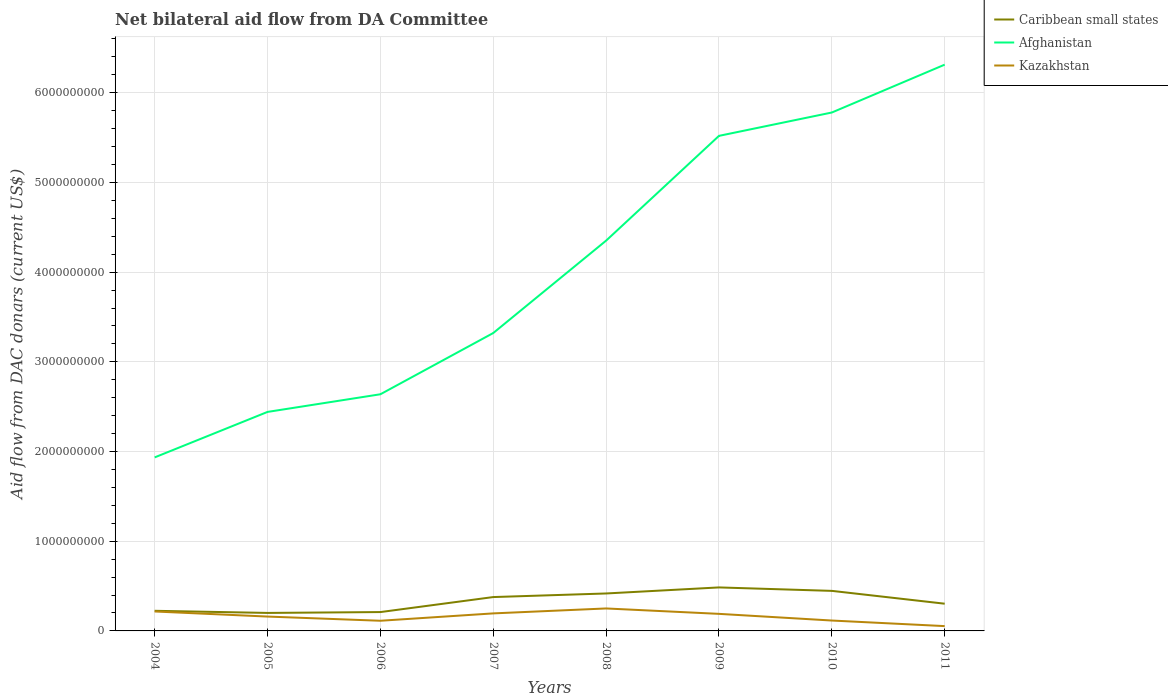How many different coloured lines are there?
Provide a short and direct response. 3. Does the line corresponding to Afghanistan intersect with the line corresponding to Kazakhstan?
Offer a terse response. No. Across all years, what is the maximum aid flow in in Kazakhstan?
Provide a succinct answer. 5.37e+07. In which year was the aid flow in in Kazakhstan maximum?
Offer a very short reply. 2011. What is the total aid flow in in Caribbean small states in the graph?
Offer a very short reply. 1.82e+08. What is the difference between the highest and the second highest aid flow in in Caribbean small states?
Your answer should be compact. 2.84e+08. How many years are there in the graph?
Your answer should be very brief. 8. What is the difference between two consecutive major ticks on the Y-axis?
Keep it short and to the point. 1.00e+09. Are the values on the major ticks of Y-axis written in scientific E-notation?
Your response must be concise. No. Does the graph contain grids?
Offer a very short reply. Yes. Where does the legend appear in the graph?
Provide a short and direct response. Top right. How many legend labels are there?
Your response must be concise. 3. What is the title of the graph?
Provide a short and direct response. Net bilateral aid flow from DA Committee. What is the label or title of the Y-axis?
Give a very brief answer. Aid flow from DAC donars (current US$). What is the Aid flow from DAC donars (current US$) in Caribbean small states in 2004?
Your response must be concise. 2.24e+08. What is the Aid flow from DAC donars (current US$) of Afghanistan in 2004?
Offer a very short reply. 1.93e+09. What is the Aid flow from DAC donars (current US$) in Kazakhstan in 2004?
Your response must be concise. 2.17e+08. What is the Aid flow from DAC donars (current US$) in Caribbean small states in 2005?
Provide a succinct answer. 2.01e+08. What is the Aid flow from DAC donars (current US$) of Afghanistan in 2005?
Offer a terse response. 2.44e+09. What is the Aid flow from DAC donars (current US$) of Kazakhstan in 2005?
Provide a succinct answer. 1.60e+08. What is the Aid flow from DAC donars (current US$) of Caribbean small states in 2006?
Ensure brevity in your answer.  2.10e+08. What is the Aid flow from DAC donars (current US$) of Afghanistan in 2006?
Your response must be concise. 2.64e+09. What is the Aid flow from DAC donars (current US$) of Kazakhstan in 2006?
Ensure brevity in your answer.  1.13e+08. What is the Aid flow from DAC donars (current US$) in Caribbean small states in 2007?
Provide a succinct answer. 3.77e+08. What is the Aid flow from DAC donars (current US$) of Afghanistan in 2007?
Offer a terse response. 3.32e+09. What is the Aid flow from DAC donars (current US$) in Kazakhstan in 2007?
Your response must be concise. 1.95e+08. What is the Aid flow from DAC donars (current US$) of Caribbean small states in 2008?
Your answer should be very brief. 4.18e+08. What is the Aid flow from DAC donars (current US$) of Afghanistan in 2008?
Provide a succinct answer. 4.35e+09. What is the Aid flow from DAC donars (current US$) of Kazakhstan in 2008?
Keep it short and to the point. 2.50e+08. What is the Aid flow from DAC donars (current US$) of Caribbean small states in 2009?
Give a very brief answer. 4.85e+08. What is the Aid flow from DAC donars (current US$) of Afghanistan in 2009?
Provide a succinct answer. 5.52e+09. What is the Aid flow from DAC donars (current US$) of Kazakhstan in 2009?
Provide a short and direct response. 1.90e+08. What is the Aid flow from DAC donars (current US$) in Caribbean small states in 2010?
Your answer should be compact. 4.46e+08. What is the Aid flow from DAC donars (current US$) in Afghanistan in 2010?
Give a very brief answer. 5.78e+09. What is the Aid flow from DAC donars (current US$) in Kazakhstan in 2010?
Ensure brevity in your answer.  1.16e+08. What is the Aid flow from DAC donars (current US$) in Caribbean small states in 2011?
Ensure brevity in your answer.  3.03e+08. What is the Aid flow from DAC donars (current US$) in Afghanistan in 2011?
Provide a short and direct response. 6.31e+09. What is the Aid flow from DAC donars (current US$) of Kazakhstan in 2011?
Ensure brevity in your answer.  5.37e+07. Across all years, what is the maximum Aid flow from DAC donars (current US$) of Caribbean small states?
Ensure brevity in your answer.  4.85e+08. Across all years, what is the maximum Aid flow from DAC donars (current US$) in Afghanistan?
Provide a short and direct response. 6.31e+09. Across all years, what is the maximum Aid flow from DAC donars (current US$) of Kazakhstan?
Your answer should be compact. 2.50e+08. Across all years, what is the minimum Aid flow from DAC donars (current US$) of Caribbean small states?
Your answer should be compact. 2.01e+08. Across all years, what is the minimum Aid flow from DAC donars (current US$) of Afghanistan?
Give a very brief answer. 1.93e+09. Across all years, what is the minimum Aid flow from DAC donars (current US$) in Kazakhstan?
Your answer should be very brief. 5.37e+07. What is the total Aid flow from DAC donars (current US$) in Caribbean small states in the graph?
Make the answer very short. 2.67e+09. What is the total Aid flow from DAC donars (current US$) of Afghanistan in the graph?
Make the answer very short. 3.23e+1. What is the total Aid flow from DAC donars (current US$) in Kazakhstan in the graph?
Provide a short and direct response. 1.30e+09. What is the difference between the Aid flow from DAC donars (current US$) of Caribbean small states in 2004 and that in 2005?
Your answer should be compact. 2.37e+07. What is the difference between the Aid flow from DAC donars (current US$) in Afghanistan in 2004 and that in 2005?
Offer a very short reply. -5.07e+08. What is the difference between the Aid flow from DAC donars (current US$) in Kazakhstan in 2004 and that in 2005?
Provide a short and direct response. 5.66e+07. What is the difference between the Aid flow from DAC donars (current US$) in Caribbean small states in 2004 and that in 2006?
Your response must be concise. 1.42e+07. What is the difference between the Aid flow from DAC donars (current US$) in Afghanistan in 2004 and that in 2006?
Your answer should be very brief. -7.04e+08. What is the difference between the Aid flow from DAC donars (current US$) in Kazakhstan in 2004 and that in 2006?
Make the answer very short. 1.03e+08. What is the difference between the Aid flow from DAC donars (current US$) of Caribbean small states in 2004 and that in 2007?
Provide a short and direct response. -1.53e+08. What is the difference between the Aid flow from DAC donars (current US$) in Afghanistan in 2004 and that in 2007?
Make the answer very short. -1.39e+09. What is the difference between the Aid flow from DAC donars (current US$) in Kazakhstan in 2004 and that in 2007?
Your response must be concise. 2.12e+07. What is the difference between the Aid flow from DAC donars (current US$) of Caribbean small states in 2004 and that in 2008?
Provide a short and direct response. -1.93e+08. What is the difference between the Aid flow from DAC donars (current US$) in Afghanistan in 2004 and that in 2008?
Provide a short and direct response. -2.42e+09. What is the difference between the Aid flow from DAC donars (current US$) in Kazakhstan in 2004 and that in 2008?
Ensure brevity in your answer.  -3.38e+07. What is the difference between the Aid flow from DAC donars (current US$) of Caribbean small states in 2004 and that in 2009?
Offer a very short reply. -2.61e+08. What is the difference between the Aid flow from DAC donars (current US$) in Afghanistan in 2004 and that in 2009?
Offer a terse response. -3.58e+09. What is the difference between the Aid flow from DAC donars (current US$) of Kazakhstan in 2004 and that in 2009?
Your response must be concise. 2.64e+07. What is the difference between the Aid flow from DAC donars (current US$) in Caribbean small states in 2004 and that in 2010?
Offer a very short reply. -2.22e+08. What is the difference between the Aid flow from DAC donars (current US$) of Afghanistan in 2004 and that in 2010?
Give a very brief answer. -3.84e+09. What is the difference between the Aid flow from DAC donars (current US$) of Kazakhstan in 2004 and that in 2010?
Your answer should be very brief. 1.01e+08. What is the difference between the Aid flow from DAC donars (current US$) of Caribbean small states in 2004 and that in 2011?
Provide a succinct answer. -7.90e+07. What is the difference between the Aid flow from DAC donars (current US$) of Afghanistan in 2004 and that in 2011?
Your response must be concise. -4.38e+09. What is the difference between the Aid flow from DAC donars (current US$) of Kazakhstan in 2004 and that in 2011?
Give a very brief answer. 1.63e+08. What is the difference between the Aid flow from DAC donars (current US$) of Caribbean small states in 2005 and that in 2006?
Give a very brief answer. -9.56e+06. What is the difference between the Aid flow from DAC donars (current US$) in Afghanistan in 2005 and that in 2006?
Ensure brevity in your answer.  -1.97e+08. What is the difference between the Aid flow from DAC donars (current US$) in Kazakhstan in 2005 and that in 2006?
Give a very brief answer. 4.67e+07. What is the difference between the Aid flow from DAC donars (current US$) in Caribbean small states in 2005 and that in 2007?
Offer a very short reply. -1.77e+08. What is the difference between the Aid flow from DAC donars (current US$) of Afghanistan in 2005 and that in 2007?
Provide a short and direct response. -8.80e+08. What is the difference between the Aid flow from DAC donars (current US$) in Kazakhstan in 2005 and that in 2007?
Make the answer very short. -3.54e+07. What is the difference between the Aid flow from DAC donars (current US$) in Caribbean small states in 2005 and that in 2008?
Keep it short and to the point. -2.17e+08. What is the difference between the Aid flow from DAC donars (current US$) in Afghanistan in 2005 and that in 2008?
Ensure brevity in your answer.  -1.91e+09. What is the difference between the Aid flow from DAC donars (current US$) of Kazakhstan in 2005 and that in 2008?
Your answer should be very brief. -9.04e+07. What is the difference between the Aid flow from DAC donars (current US$) of Caribbean small states in 2005 and that in 2009?
Your response must be concise. -2.84e+08. What is the difference between the Aid flow from DAC donars (current US$) in Afghanistan in 2005 and that in 2009?
Give a very brief answer. -3.08e+09. What is the difference between the Aid flow from DAC donars (current US$) in Kazakhstan in 2005 and that in 2009?
Make the answer very short. -3.02e+07. What is the difference between the Aid flow from DAC donars (current US$) of Caribbean small states in 2005 and that in 2010?
Keep it short and to the point. -2.46e+08. What is the difference between the Aid flow from DAC donars (current US$) in Afghanistan in 2005 and that in 2010?
Keep it short and to the point. -3.34e+09. What is the difference between the Aid flow from DAC donars (current US$) in Kazakhstan in 2005 and that in 2010?
Your answer should be compact. 4.42e+07. What is the difference between the Aid flow from DAC donars (current US$) of Caribbean small states in 2005 and that in 2011?
Your response must be concise. -1.03e+08. What is the difference between the Aid flow from DAC donars (current US$) of Afghanistan in 2005 and that in 2011?
Your answer should be compact. -3.87e+09. What is the difference between the Aid flow from DAC donars (current US$) of Kazakhstan in 2005 and that in 2011?
Offer a very short reply. 1.06e+08. What is the difference between the Aid flow from DAC donars (current US$) in Caribbean small states in 2006 and that in 2007?
Make the answer very short. -1.67e+08. What is the difference between the Aid flow from DAC donars (current US$) of Afghanistan in 2006 and that in 2007?
Ensure brevity in your answer.  -6.83e+08. What is the difference between the Aid flow from DAC donars (current US$) of Kazakhstan in 2006 and that in 2007?
Provide a short and direct response. -8.22e+07. What is the difference between the Aid flow from DAC donars (current US$) in Caribbean small states in 2006 and that in 2008?
Provide a short and direct response. -2.07e+08. What is the difference between the Aid flow from DAC donars (current US$) in Afghanistan in 2006 and that in 2008?
Provide a succinct answer. -1.71e+09. What is the difference between the Aid flow from DAC donars (current US$) of Kazakhstan in 2006 and that in 2008?
Your answer should be very brief. -1.37e+08. What is the difference between the Aid flow from DAC donars (current US$) of Caribbean small states in 2006 and that in 2009?
Keep it short and to the point. -2.75e+08. What is the difference between the Aid flow from DAC donars (current US$) in Afghanistan in 2006 and that in 2009?
Offer a very short reply. -2.88e+09. What is the difference between the Aid flow from DAC donars (current US$) in Kazakhstan in 2006 and that in 2009?
Give a very brief answer. -7.70e+07. What is the difference between the Aid flow from DAC donars (current US$) in Caribbean small states in 2006 and that in 2010?
Make the answer very short. -2.36e+08. What is the difference between the Aid flow from DAC donars (current US$) of Afghanistan in 2006 and that in 2010?
Give a very brief answer. -3.14e+09. What is the difference between the Aid flow from DAC donars (current US$) of Kazakhstan in 2006 and that in 2010?
Give a very brief answer. -2.47e+06. What is the difference between the Aid flow from DAC donars (current US$) of Caribbean small states in 2006 and that in 2011?
Ensure brevity in your answer.  -9.32e+07. What is the difference between the Aid flow from DAC donars (current US$) of Afghanistan in 2006 and that in 2011?
Provide a short and direct response. -3.67e+09. What is the difference between the Aid flow from DAC donars (current US$) in Kazakhstan in 2006 and that in 2011?
Provide a succinct answer. 5.96e+07. What is the difference between the Aid flow from DAC donars (current US$) of Caribbean small states in 2007 and that in 2008?
Provide a succinct answer. -4.00e+07. What is the difference between the Aid flow from DAC donars (current US$) of Afghanistan in 2007 and that in 2008?
Keep it short and to the point. -1.03e+09. What is the difference between the Aid flow from DAC donars (current US$) in Kazakhstan in 2007 and that in 2008?
Your answer should be compact. -5.50e+07. What is the difference between the Aid flow from DAC donars (current US$) of Caribbean small states in 2007 and that in 2009?
Give a very brief answer. -1.08e+08. What is the difference between the Aid flow from DAC donars (current US$) in Afghanistan in 2007 and that in 2009?
Keep it short and to the point. -2.20e+09. What is the difference between the Aid flow from DAC donars (current US$) in Kazakhstan in 2007 and that in 2009?
Give a very brief answer. 5.20e+06. What is the difference between the Aid flow from DAC donars (current US$) in Caribbean small states in 2007 and that in 2010?
Offer a very short reply. -6.90e+07. What is the difference between the Aid flow from DAC donars (current US$) in Afghanistan in 2007 and that in 2010?
Give a very brief answer. -2.46e+09. What is the difference between the Aid flow from DAC donars (current US$) of Kazakhstan in 2007 and that in 2010?
Your response must be concise. 7.97e+07. What is the difference between the Aid flow from DAC donars (current US$) of Caribbean small states in 2007 and that in 2011?
Provide a succinct answer. 7.40e+07. What is the difference between the Aid flow from DAC donars (current US$) in Afghanistan in 2007 and that in 2011?
Your answer should be very brief. -2.99e+09. What is the difference between the Aid flow from DAC donars (current US$) of Kazakhstan in 2007 and that in 2011?
Offer a very short reply. 1.42e+08. What is the difference between the Aid flow from DAC donars (current US$) of Caribbean small states in 2008 and that in 2009?
Provide a short and direct response. -6.75e+07. What is the difference between the Aid flow from DAC donars (current US$) in Afghanistan in 2008 and that in 2009?
Provide a succinct answer. -1.17e+09. What is the difference between the Aid flow from DAC donars (current US$) in Kazakhstan in 2008 and that in 2009?
Offer a very short reply. 6.02e+07. What is the difference between the Aid flow from DAC donars (current US$) of Caribbean small states in 2008 and that in 2010?
Ensure brevity in your answer.  -2.90e+07. What is the difference between the Aid flow from DAC donars (current US$) of Afghanistan in 2008 and that in 2010?
Your answer should be compact. -1.43e+09. What is the difference between the Aid flow from DAC donars (current US$) in Kazakhstan in 2008 and that in 2010?
Make the answer very short. 1.35e+08. What is the difference between the Aid flow from DAC donars (current US$) of Caribbean small states in 2008 and that in 2011?
Offer a very short reply. 1.14e+08. What is the difference between the Aid flow from DAC donars (current US$) in Afghanistan in 2008 and that in 2011?
Provide a succinct answer. -1.96e+09. What is the difference between the Aid flow from DAC donars (current US$) in Kazakhstan in 2008 and that in 2011?
Provide a succinct answer. 1.97e+08. What is the difference between the Aid flow from DAC donars (current US$) in Caribbean small states in 2009 and that in 2010?
Ensure brevity in your answer.  3.85e+07. What is the difference between the Aid flow from DAC donars (current US$) in Afghanistan in 2009 and that in 2010?
Keep it short and to the point. -2.60e+08. What is the difference between the Aid flow from DAC donars (current US$) of Kazakhstan in 2009 and that in 2010?
Provide a succinct answer. 7.45e+07. What is the difference between the Aid flow from DAC donars (current US$) of Caribbean small states in 2009 and that in 2011?
Your response must be concise. 1.82e+08. What is the difference between the Aid flow from DAC donars (current US$) of Afghanistan in 2009 and that in 2011?
Keep it short and to the point. -7.94e+08. What is the difference between the Aid flow from DAC donars (current US$) in Kazakhstan in 2009 and that in 2011?
Keep it short and to the point. 1.37e+08. What is the difference between the Aid flow from DAC donars (current US$) of Caribbean small states in 2010 and that in 2011?
Your answer should be compact. 1.43e+08. What is the difference between the Aid flow from DAC donars (current US$) of Afghanistan in 2010 and that in 2011?
Provide a succinct answer. -5.34e+08. What is the difference between the Aid flow from DAC donars (current US$) of Kazakhstan in 2010 and that in 2011?
Your answer should be very brief. 6.21e+07. What is the difference between the Aid flow from DAC donars (current US$) in Caribbean small states in 2004 and the Aid flow from DAC donars (current US$) in Afghanistan in 2005?
Offer a terse response. -2.22e+09. What is the difference between the Aid flow from DAC donars (current US$) in Caribbean small states in 2004 and the Aid flow from DAC donars (current US$) in Kazakhstan in 2005?
Provide a succinct answer. 6.44e+07. What is the difference between the Aid flow from DAC donars (current US$) in Afghanistan in 2004 and the Aid flow from DAC donars (current US$) in Kazakhstan in 2005?
Your answer should be very brief. 1.77e+09. What is the difference between the Aid flow from DAC donars (current US$) in Caribbean small states in 2004 and the Aid flow from DAC donars (current US$) in Afghanistan in 2006?
Offer a very short reply. -2.41e+09. What is the difference between the Aid flow from DAC donars (current US$) in Caribbean small states in 2004 and the Aid flow from DAC donars (current US$) in Kazakhstan in 2006?
Give a very brief answer. 1.11e+08. What is the difference between the Aid flow from DAC donars (current US$) of Afghanistan in 2004 and the Aid flow from DAC donars (current US$) of Kazakhstan in 2006?
Ensure brevity in your answer.  1.82e+09. What is the difference between the Aid flow from DAC donars (current US$) in Caribbean small states in 2004 and the Aid flow from DAC donars (current US$) in Afghanistan in 2007?
Your response must be concise. -3.10e+09. What is the difference between the Aid flow from DAC donars (current US$) in Caribbean small states in 2004 and the Aid flow from DAC donars (current US$) in Kazakhstan in 2007?
Keep it short and to the point. 2.89e+07. What is the difference between the Aid flow from DAC donars (current US$) in Afghanistan in 2004 and the Aid flow from DAC donars (current US$) in Kazakhstan in 2007?
Give a very brief answer. 1.74e+09. What is the difference between the Aid flow from DAC donars (current US$) in Caribbean small states in 2004 and the Aid flow from DAC donars (current US$) in Afghanistan in 2008?
Ensure brevity in your answer.  -4.13e+09. What is the difference between the Aid flow from DAC donars (current US$) of Caribbean small states in 2004 and the Aid flow from DAC donars (current US$) of Kazakhstan in 2008?
Provide a short and direct response. -2.60e+07. What is the difference between the Aid flow from DAC donars (current US$) in Afghanistan in 2004 and the Aid flow from DAC donars (current US$) in Kazakhstan in 2008?
Provide a short and direct response. 1.68e+09. What is the difference between the Aid flow from DAC donars (current US$) of Caribbean small states in 2004 and the Aid flow from DAC donars (current US$) of Afghanistan in 2009?
Your answer should be very brief. -5.29e+09. What is the difference between the Aid flow from DAC donars (current US$) of Caribbean small states in 2004 and the Aid flow from DAC donars (current US$) of Kazakhstan in 2009?
Keep it short and to the point. 3.41e+07. What is the difference between the Aid flow from DAC donars (current US$) of Afghanistan in 2004 and the Aid flow from DAC donars (current US$) of Kazakhstan in 2009?
Provide a succinct answer. 1.74e+09. What is the difference between the Aid flow from DAC donars (current US$) of Caribbean small states in 2004 and the Aid flow from DAC donars (current US$) of Afghanistan in 2010?
Your response must be concise. -5.56e+09. What is the difference between the Aid flow from DAC donars (current US$) of Caribbean small states in 2004 and the Aid flow from DAC donars (current US$) of Kazakhstan in 2010?
Offer a terse response. 1.09e+08. What is the difference between the Aid flow from DAC donars (current US$) in Afghanistan in 2004 and the Aid flow from DAC donars (current US$) in Kazakhstan in 2010?
Make the answer very short. 1.82e+09. What is the difference between the Aid flow from DAC donars (current US$) in Caribbean small states in 2004 and the Aid flow from DAC donars (current US$) in Afghanistan in 2011?
Offer a terse response. -6.09e+09. What is the difference between the Aid flow from DAC donars (current US$) of Caribbean small states in 2004 and the Aid flow from DAC donars (current US$) of Kazakhstan in 2011?
Keep it short and to the point. 1.71e+08. What is the difference between the Aid flow from DAC donars (current US$) of Afghanistan in 2004 and the Aid flow from DAC donars (current US$) of Kazakhstan in 2011?
Offer a terse response. 1.88e+09. What is the difference between the Aid flow from DAC donars (current US$) in Caribbean small states in 2005 and the Aid flow from DAC donars (current US$) in Afghanistan in 2006?
Provide a short and direct response. -2.44e+09. What is the difference between the Aid flow from DAC donars (current US$) of Caribbean small states in 2005 and the Aid flow from DAC donars (current US$) of Kazakhstan in 2006?
Keep it short and to the point. 8.74e+07. What is the difference between the Aid flow from DAC donars (current US$) in Afghanistan in 2005 and the Aid flow from DAC donars (current US$) in Kazakhstan in 2006?
Provide a succinct answer. 2.33e+09. What is the difference between the Aid flow from DAC donars (current US$) of Caribbean small states in 2005 and the Aid flow from DAC donars (current US$) of Afghanistan in 2007?
Your answer should be compact. -3.12e+09. What is the difference between the Aid flow from DAC donars (current US$) in Caribbean small states in 2005 and the Aid flow from DAC donars (current US$) in Kazakhstan in 2007?
Offer a terse response. 5.20e+06. What is the difference between the Aid flow from DAC donars (current US$) in Afghanistan in 2005 and the Aid flow from DAC donars (current US$) in Kazakhstan in 2007?
Make the answer very short. 2.25e+09. What is the difference between the Aid flow from DAC donars (current US$) in Caribbean small states in 2005 and the Aid flow from DAC donars (current US$) in Afghanistan in 2008?
Provide a succinct answer. -4.15e+09. What is the difference between the Aid flow from DAC donars (current US$) of Caribbean small states in 2005 and the Aid flow from DAC donars (current US$) of Kazakhstan in 2008?
Your answer should be compact. -4.98e+07. What is the difference between the Aid flow from DAC donars (current US$) in Afghanistan in 2005 and the Aid flow from DAC donars (current US$) in Kazakhstan in 2008?
Keep it short and to the point. 2.19e+09. What is the difference between the Aid flow from DAC donars (current US$) in Caribbean small states in 2005 and the Aid flow from DAC donars (current US$) in Afghanistan in 2009?
Ensure brevity in your answer.  -5.32e+09. What is the difference between the Aid flow from DAC donars (current US$) in Caribbean small states in 2005 and the Aid flow from DAC donars (current US$) in Kazakhstan in 2009?
Provide a succinct answer. 1.04e+07. What is the difference between the Aid flow from DAC donars (current US$) in Afghanistan in 2005 and the Aid flow from DAC donars (current US$) in Kazakhstan in 2009?
Keep it short and to the point. 2.25e+09. What is the difference between the Aid flow from DAC donars (current US$) in Caribbean small states in 2005 and the Aid flow from DAC donars (current US$) in Afghanistan in 2010?
Keep it short and to the point. -5.58e+09. What is the difference between the Aid flow from DAC donars (current US$) of Caribbean small states in 2005 and the Aid flow from DAC donars (current US$) of Kazakhstan in 2010?
Make the answer very short. 8.49e+07. What is the difference between the Aid flow from DAC donars (current US$) in Afghanistan in 2005 and the Aid flow from DAC donars (current US$) in Kazakhstan in 2010?
Offer a terse response. 2.33e+09. What is the difference between the Aid flow from DAC donars (current US$) in Caribbean small states in 2005 and the Aid flow from DAC donars (current US$) in Afghanistan in 2011?
Offer a terse response. -6.11e+09. What is the difference between the Aid flow from DAC donars (current US$) in Caribbean small states in 2005 and the Aid flow from DAC donars (current US$) in Kazakhstan in 2011?
Your answer should be very brief. 1.47e+08. What is the difference between the Aid flow from DAC donars (current US$) in Afghanistan in 2005 and the Aid flow from DAC donars (current US$) in Kazakhstan in 2011?
Your answer should be compact. 2.39e+09. What is the difference between the Aid flow from DAC donars (current US$) of Caribbean small states in 2006 and the Aid flow from DAC donars (current US$) of Afghanistan in 2007?
Ensure brevity in your answer.  -3.11e+09. What is the difference between the Aid flow from DAC donars (current US$) of Caribbean small states in 2006 and the Aid flow from DAC donars (current US$) of Kazakhstan in 2007?
Offer a very short reply. 1.48e+07. What is the difference between the Aid flow from DAC donars (current US$) of Afghanistan in 2006 and the Aid flow from DAC donars (current US$) of Kazakhstan in 2007?
Offer a terse response. 2.44e+09. What is the difference between the Aid flow from DAC donars (current US$) of Caribbean small states in 2006 and the Aid flow from DAC donars (current US$) of Afghanistan in 2008?
Give a very brief answer. -4.14e+09. What is the difference between the Aid flow from DAC donars (current US$) in Caribbean small states in 2006 and the Aid flow from DAC donars (current US$) in Kazakhstan in 2008?
Keep it short and to the point. -4.02e+07. What is the difference between the Aid flow from DAC donars (current US$) in Afghanistan in 2006 and the Aid flow from DAC donars (current US$) in Kazakhstan in 2008?
Provide a succinct answer. 2.39e+09. What is the difference between the Aid flow from DAC donars (current US$) of Caribbean small states in 2006 and the Aid flow from DAC donars (current US$) of Afghanistan in 2009?
Offer a terse response. -5.31e+09. What is the difference between the Aid flow from DAC donars (current US$) of Caribbean small states in 2006 and the Aid flow from DAC donars (current US$) of Kazakhstan in 2009?
Offer a very short reply. 2.00e+07. What is the difference between the Aid flow from DAC donars (current US$) of Afghanistan in 2006 and the Aid flow from DAC donars (current US$) of Kazakhstan in 2009?
Ensure brevity in your answer.  2.45e+09. What is the difference between the Aid flow from DAC donars (current US$) in Caribbean small states in 2006 and the Aid flow from DAC donars (current US$) in Afghanistan in 2010?
Your answer should be very brief. -5.57e+09. What is the difference between the Aid flow from DAC donars (current US$) in Caribbean small states in 2006 and the Aid flow from DAC donars (current US$) in Kazakhstan in 2010?
Offer a terse response. 9.44e+07. What is the difference between the Aid flow from DAC donars (current US$) of Afghanistan in 2006 and the Aid flow from DAC donars (current US$) of Kazakhstan in 2010?
Keep it short and to the point. 2.52e+09. What is the difference between the Aid flow from DAC donars (current US$) in Caribbean small states in 2006 and the Aid flow from DAC donars (current US$) in Afghanistan in 2011?
Keep it short and to the point. -6.10e+09. What is the difference between the Aid flow from DAC donars (current US$) of Caribbean small states in 2006 and the Aid flow from DAC donars (current US$) of Kazakhstan in 2011?
Provide a succinct answer. 1.57e+08. What is the difference between the Aid flow from DAC donars (current US$) in Afghanistan in 2006 and the Aid flow from DAC donars (current US$) in Kazakhstan in 2011?
Make the answer very short. 2.58e+09. What is the difference between the Aid flow from DAC donars (current US$) of Caribbean small states in 2007 and the Aid flow from DAC donars (current US$) of Afghanistan in 2008?
Offer a terse response. -3.97e+09. What is the difference between the Aid flow from DAC donars (current US$) in Caribbean small states in 2007 and the Aid flow from DAC donars (current US$) in Kazakhstan in 2008?
Your response must be concise. 1.27e+08. What is the difference between the Aid flow from DAC donars (current US$) of Afghanistan in 2007 and the Aid flow from DAC donars (current US$) of Kazakhstan in 2008?
Ensure brevity in your answer.  3.07e+09. What is the difference between the Aid flow from DAC donars (current US$) of Caribbean small states in 2007 and the Aid flow from DAC donars (current US$) of Afghanistan in 2009?
Your response must be concise. -5.14e+09. What is the difference between the Aid flow from DAC donars (current US$) of Caribbean small states in 2007 and the Aid flow from DAC donars (current US$) of Kazakhstan in 2009?
Ensure brevity in your answer.  1.87e+08. What is the difference between the Aid flow from DAC donars (current US$) of Afghanistan in 2007 and the Aid flow from DAC donars (current US$) of Kazakhstan in 2009?
Provide a short and direct response. 3.13e+09. What is the difference between the Aid flow from DAC donars (current US$) of Caribbean small states in 2007 and the Aid flow from DAC donars (current US$) of Afghanistan in 2010?
Provide a succinct answer. -5.40e+09. What is the difference between the Aid flow from DAC donars (current US$) of Caribbean small states in 2007 and the Aid flow from DAC donars (current US$) of Kazakhstan in 2010?
Give a very brief answer. 2.62e+08. What is the difference between the Aid flow from DAC donars (current US$) of Afghanistan in 2007 and the Aid flow from DAC donars (current US$) of Kazakhstan in 2010?
Your answer should be very brief. 3.21e+09. What is the difference between the Aid flow from DAC donars (current US$) of Caribbean small states in 2007 and the Aid flow from DAC donars (current US$) of Afghanistan in 2011?
Your answer should be very brief. -5.94e+09. What is the difference between the Aid flow from DAC donars (current US$) of Caribbean small states in 2007 and the Aid flow from DAC donars (current US$) of Kazakhstan in 2011?
Your response must be concise. 3.24e+08. What is the difference between the Aid flow from DAC donars (current US$) in Afghanistan in 2007 and the Aid flow from DAC donars (current US$) in Kazakhstan in 2011?
Provide a short and direct response. 3.27e+09. What is the difference between the Aid flow from DAC donars (current US$) of Caribbean small states in 2008 and the Aid flow from DAC donars (current US$) of Afghanistan in 2009?
Make the answer very short. -5.10e+09. What is the difference between the Aid flow from DAC donars (current US$) in Caribbean small states in 2008 and the Aid flow from DAC donars (current US$) in Kazakhstan in 2009?
Provide a succinct answer. 2.27e+08. What is the difference between the Aid flow from DAC donars (current US$) in Afghanistan in 2008 and the Aid flow from DAC donars (current US$) in Kazakhstan in 2009?
Keep it short and to the point. 4.16e+09. What is the difference between the Aid flow from DAC donars (current US$) of Caribbean small states in 2008 and the Aid flow from DAC donars (current US$) of Afghanistan in 2010?
Your response must be concise. -5.36e+09. What is the difference between the Aid flow from DAC donars (current US$) of Caribbean small states in 2008 and the Aid flow from DAC donars (current US$) of Kazakhstan in 2010?
Your response must be concise. 3.02e+08. What is the difference between the Aid flow from DAC donars (current US$) in Afghanistan in 2008 and the Aid flow from DAC donars (current US$) in Kazakhstan in 2010?
Your answer should be compact. 4.24e+09. What is the difference between the Aid flow from DAC donars (current US$) of Caribbean small states in 2008 and the Aid flow from DAC donars (current US$) of Afghanistan in 2011?
Ensure brevity in your answer.  -5.90e+09. What is the difference between the Aid flow from DAC donars (current US$) of Caribbean small states in 2008 and the Aid flow from DAC donars (current US$) of Kazakhstan in 2011?
Your answer should be very brief. 3.64e+08. What is the difference between the Aid flow from DAC donars (current US$) in Afghanistan in 2008 and the Aid flow from DAC donars (current US$) in Kazakhstan in 2011?
Provide a short and direct response. 4.30e+09. What is the difference between the Aid flow from DAC donars (current US$) of Caribbean small states in 2009 and the Aid flow from DAC donars (current US$) of Afghanistan in 2010?
Provide a succinct answer. -5.29e+09. What is the difference between the Aid flow from DAC donars (current US$) of Caribbean small states in 2009 and the Aid flow from DAC donars (current US$) of Kazakhstan in 2010?
Your answer should be compact. 3.69e+08. What is the difference between the Aid flow from DAC donars (current US$) in Afghanistan in 2009 and the Aid flow from DAC donars (current US$) in Kazakhstan in 2010?
Provide a short and direct response. 5.40e+09. What is the difference between the Aid flow from DAC donars (current US$) of Caribbean small states in 2009 and the Aid flow from DAC donars (current US$) of Afghanistan in 2011?
Your response must be concise. -5.83e+09. What is the difference between the Aid flow from DAC donars (current US$) in Caribbean small states in 2009 and the Aid flow from DAC donars (current US$) in Kazakhstan in 2011?
Your answer should be compact. 4.31e+08. What is the difference between the Aid flow from DAC donars (current US$) in Afghanistan in 2009 and the Aid flow from DAC donars (current US$) in Kazakhstan in 2011?
Provide a short and direct response. 5.47e+09. What is the difference between the Aid flow from DAC donars (current US$) of Caribbean small states in 2010 and the Aid flow from DAC donars (current US$) of Afghanistan in 2011?
Give a very brief answer. -5.87e+09. What is the difference between the Aid flow from DAC donars (current US$) of Caribbean small states in 2010 and the Aid flow from DAC donars (current US$) of Kazakhstan in 2011?
Ensure brevity in your answer.  3.93e+08. What is the difference between the Aid flow from DAC donars (current US$) in Afghanistan in 2010 and the Aid flow from DAC donars (current US$) in Kazakhstan in 2011?
Your answer should be very brief. 5.73e+09. What is the average Aid flow from DAC donars (current US$) of Caribbean small states per year?
Your answer should be very brief. 3.33e+08. What is the average Aid flow from DAC donars (current US$) of Afghanistan per year?
Offer a very short reply. 4.04e+09. What is the average Aid flow from DAC donars (current US$) of Kazakhstan per year?
Keep it short and to the point. 1.62e+08. In the year 2004, what is the difference between the Aid flow from DAC donars (current US$) in Caribbean small states and Aid flow from DAC donars (current US$) in Afghanistan?
Keep it short and to the point. -1.71e+09. In the year 2004, what is the difference between the Aid flow from DAC donars (current US$) in Caribbean small states and Aid flow from DAC donars (current US$) in Kazakhstan?
Offer a terse response. 7.76e+06. In the year 2004, what is the difference between the Aid flow from DAC donars (current US$) in Afghanistan and Aid flow from DAC donars (current US$) in Kazakhstan?
Provide a succinct answer. 1.72e+09. In the year 2005, what is the difference between the Aid flow from DAC donars (current US$) in Caribbean small states and Aid flow from DAC donars (current US$) in Afghanistan?
Your response must be concise. -2.24e+09. In the year 2005, what is the difference between the Aid flow from DAC donars (current US$) of Caribbean small states and Aid flow from DAC donars (current US$) of Kazakhstan?
Keep it short and to the point. 4.06e+07. In the year 2005, what is the difference between the Aid flow from DAC donars (current US$) in Afghanistan and Aid flow from DAC donars (current US$) in Kazakhstan?
Keep it short and to the point. 2.28e+09. In the year 2006, what is the difference between the Aid flow from DAC donars (current US$) in Caribbean small states and Aid flow from DAC donars (current US$) in Afghanistan?
Offer a very short reply. -2.43e+09. In the year 2006, what is the difference between the Aid flow from DAC donars (current US$) of Caribbean small states and Aid flow from DAC donars (current US$) of Kazakhstan?
Your answer should be compact. 9.69e+07. In the year 2006, what is the difference between the Aid flow from DAC donars (current US$) in Afghanistan and Aid flow from DAC donars (current US$) in Kazakhstan?
Make the answer very short. 2.53e+09. In the year 2007, what is the difference between the Aid flow from DAC donars (current US$) in Caribbean small states and Aid flow from DAC donars (current US$) in Afghanistan?
Your response must be concise. -2.94e+09. In the year 2007, what is the difference between the Aid flow from DAC donars (current US$) in Caribbean small states and Aid flow from DAC donars (current US$) in Kazakhstan?
Give a very brief answer. 1.82e+08. In the year 2007, what is the difference between the Aid flow from DAC donars (current US$) of Afghanistan and Aid flow from DAC donars (current US$) of Kazakhstan?
Your answer should be compact. 3.13e+09. In the year 2008, what is the difference between the Aid flow from DAC donars (current US$) of Caribbean small states and Aid flow from DAC donars (current US$) of Afghanistan?
Offer a terse response. -3.93e+09. In the year 2008, what is the difference between the Aid flow from DAC donars (current US$) of Caribbean small states and Aid flow from DAC donars (current US$) of Kazakhstan?
Ensure brevity in your answer.  1.67e+08. In the year 2008, what is the difference between the Aid flow from DAC donars (current US$) in Afghanistan and Aid flow from DAC donars (current US$) in Kazakhstan?
Your response must be concise. 4.10e+09. In the year 2009, what is the difference between the Aid flow from DAC donars (current US$) of Caribbean small states and Aid flow from DAC donars (current US$) of Afghanistan?
Your answer should be compact. -5.03e+09. In the year 2009, what is the difference between the Aid flow from DAC donars (current US$) in Caribbean small states and Aid flow from DAC donars (current US$) in Kazakhstan?
Offer a terse response. 2.95e+08. In the year 2009, what is the difference between the Aid flow from DAC donars (current US$) in Afghanistan and Aid flow from DAC donars (current US$) in Kazakhstan?
Offer a terse response. 5.33e+09. In the year 2010, what is the difference between the Aid flow from DAC donars (current US$) in Caribbean small states and Aid flow from DAC donars (current US$) in Afghanistan?
Make the answer very short. -5.33e+09. In the year 2010, what is the difference between the Aid flow from DAC donars (current US$) in Caribbean small states and Aid flow from DAC donars (current US$) in Kazakhstan?
Ensure brevity in your answer.  3.31e+08. In the year 2010, what is the difference between the Aid flow from DAC donars (current US$) in Afghanistan and Aid flow from DAC donars (current US$) in Kazakhstan?
Ensure brevity in your answer.  5.66e+09. In the year 2011, what is the difference between the Aid flow from DAC donars (current US$) in Caribbean small states and Aid flow from DAC donars (current US$) in Afghanistan?
Provide a short and direct response. -6.01e+09. In the year 2011, what is the difference between the Aid flow from DAC donars (current US$) in Caribbean small states and Aid flow from DAC donars (current US$) in Kazakhstan?
Provide a succinct answer. 2.50e+08. In the year 2011, what is the difference between the Aid flow from DAC donars (current US$) in Afghanistan and Aid flow from DAC donars (current US$) in Kazakhstan?
Give a very brief answer. 6.26e+09. What is the ratio of the Aid flow from DAC donars (current US$) of Caribbean small states in 2004 to that in 2005?
Keep it short and to the point. 1.12. What is the ratio of the Aid flow from DAC donars (current US$) in Afghanistan in 2004 to that in 2005?
Give a very brief answer. 0.79. What is the ratio of the Aid flow from DAC donars (current US$) of Kazakhstan in 2004 to that in 2005?
Your response must be concise. 1.35. What is the ratio of the Aid flow from DAC donars (current US$) in Caribbean small states in 2004 to that in 2006?
Keep it short and to the point. 1.07. What is the ratio of the Aid flow from DAC donars (current US$) in Afghanistan in 2004 to that in 2006?
Your response must be concise. 0.73. What is the ratio of the Aid flow from DAC donars (current US$) of Kazakhstan in 2004 to that in 2006?
Give a very brief answer. 1.91. What is the ratio of the Aid flow from DAC donars (current US$) in Caribbean small states in 2004 to that in 2007?
Your answer should be compact. 0.59. What is the ratio of the Aid flow from DAC donars (current US$) of Afghanistan in 2004 to that in 2007?
Ensure brevity in your answer.  0.58. What is the ratio of the Aid flow from DAC donars (current US$) of Kazakhstan in 2004 to that in 2007?
Your response must be concise. 1.11. What is the ratio of the Aid flow from DAC donars (current US$) in Caribbean small states in 2004 to that in 2008?
Make the answer very short. 0.54. What is the ratio of the Aid flow from DAC donars (current US$) of Afghanistan in 2004 to that in 2008?
Ensure brevity in your answer.  0.44. What is the ratio of the Aid flow from DAC donars (current US$) of Kazakhstan in 2004 to that in 2008?
Your response must be concise. 0.87. What is the ratio of the Aid flow from DAC donars (current US$) in Caribbean small states in 2004 to that in 2009?
Offer a very short reply. 0.46. What is the ratio of the Aid flow from DAC donars (current US$) of Afghanistan in 2004 to that in 2009?
Offer a very short reply. 0.35. What is the ratio of the Aid flow from DAC donars (current US$) in Kazakhstan in 2004 to that in 2009?
Make the answer very short. 1.14. What is the ratio of the Aid flow from DAC donars (current US$) of Caribbean small states in 2004 to that in 2010?
Your response must be concise. 0.5. What is the ratio of the Aid flow from DAC donars (current US$) in Afghanistan in 2004 to that in 2010?
Your response must be concise. 0.33. What is the ratio of the Aid flow from DAC donars (current US$) of Kazakhstan in 2004 to that in 2010?
Your answer should be compact. 1.87. What is the ratio of the Aid flow from DAC donars (current US$) in Caribbean small states in 2004 to that in 2011?
Provide a succinct answer. 0.74. What is the ratio of the Aid flow from DAC donars (current US$) in Afghanistan in 2004 to that in 2011?
Give a very brief answer. 0.31. What is the ratio of the Aid flow from DAC donars (current US$) in Kazakhstan in 2004 to that in 2011?
Keep it short and to the point. 4.04. What is the ratio of the Aid flow from DAC donars (current US$) of Caribbean small states in 2005 to that in 2006?
Your response must be concise. 0.95. What is the ratio of the Aid flow from DAC donars (current US$) in Afghanistan in 2005 to that in 2006?
Offer a very short reply. 0.93. What is the ratio of the Aid flow from DAC donars (current US$) of Kazakhstan in 2005 to that in 2006?
Offer a terse response. 1.41. What is the ratio of the Aid flow from DAC donars (current US$) in Caribbean small states in 2005 to that in 2007?
Offer a very short reply. 0.53. What is the ratio of the Aid flow from DAC donars (current US$) of Afghanistan in 2005 to that in 2007?
Provide a short and direct response. 0.74. What is the ratio of the Aid flow from DAC donars (current US$) in Kazakhstan in 2005 to that in 2007?
Provide a short and direct response. 0.82. What is the ratio of the Aid flow from DAC donars (current US$) of Caribbean small states in 2005 to that in 2008?
Provide a short and direct response. 0.48. What is the ratio of the Aid flow from DAC donars (current US$) in Afghanistan in 2005 to that in 2008?
Your answer should be compact. 0.56. What is the ratio of the Aid flow from DAC donars (current US$) in Kazakhstan in 2005 to that in 2008?
Offer a terse response. 0.64. What is the ratio of the Aid flow from DAC donars (current US$) of Caribbean small states in 2005 to that in 2009?
Give a very brief answer. 0.41. What is the ratio of the Aid flow from DAC donars (current US$) of Afghanistan in 2005 to that in 2009?
Keep it short and to the point. 0.44. What is the ratio of the Aid flow from DAC donars (current US$) of Kazakhstan in 2005 to that in 2009?
Offer a very short reply. 0.84. What is the ratio of the Aid flow from DAC donars (current US$) in Caribbean small states in 2005 to that in 2010?
Ensure brevity in your answer.  0.45. What is the ratio of the Aid flow from DAC donars (current US$) in Afghanistan in 2005 to that in 2010?
Keep it short and to the point. 0.42. What is the ratio of the Aid flow from DAC donars (current US$) in Kazakhstan in 2005 to that in 2010?
Ensure brevity in your answer.  1.38. What is the ratio of the Aid flow from DAC donars (current US$) of Caribbean small states in 2005 to that in 2011?
Give a very brief answer. 0.66. What is the ratio of the Aid flow from DAC donars (current US$) in Afghanistan in 2005 to that in 2011?
Offer a very short reply. 0.39. What is the ratio of the Aid flow from DAC donars (current US$) in Kazakhstan in 2005 to that in 2011?
Keep it short and to the point. 2.98. What is the ratio of the Aid flow from DAC donars (current US$) of Caribbean small states in 2006 to that in 2007?
Provide a short and direct response. 0.56. What is the ratio of the Aid flow from DAC donars (current US$) of Afghanistan in 2006 to that in 2007?
Offer a terse response. 0.79. What is the ratio of the Aid flow from DAC donars (current US$) in Kazakhstan in 2006 to that in 2007?
Provide a short and direct response. 0.58. What is the ratio of the Aid flow from DAC donars (current US$) of Caribbean small states in 2006 to that in 2008?
Provide a short and direct response. 0.5. What is the ratio of the Aid flow from DAC donars (current US$) in Afghanistan in 2006 to that in 2008?
Offer a very short reply. 0.61. What is the ratio of the Aid flow from DAC donars (current US$) of Kazakhstan in 2006 to that in 2008?
Keep it short and to the point. 0.45. What is the ratio of the Aid flow from DAC donars (current US$) in Caribbean small states in 2006 to that in 2009?
Provide a short and direct response. 0.43. What is the ratio of the Aid flow from DAC donars (current US$) of Afghanistan in 2006 to that in 2009?
Provide a short and direct response. 0.48. What is the ratio of the Aid flow from DAC donars (current US$) in Kazakhstan in 2006 to that in 2009?
Make the answer very short. 0.6. What is the ratio of the Aid flow from DAC donars (current US$) of Caribbean small states in 2006 to that in 2010?
Provide a succinct answer. 0.47. What is the ratio of the Aid flow from DAC donars (current US$) in Afghanistan in 2006 to that in 2010?
Your answer should be very brief. 0.46. What is the ratio of the Aid flow from DAC donars (current US$) in Kazakhstan in 2006 to that in 2010?
Give a very brief answer. 0.98. What is the ratio of the Aid flow from DAC donars (current US$) in Caribbean small states in 2006 to that in 2011?
Offer a terse response. 0.69. What is the ratio of the Aid flow from DAC donars (current US$) in Afghanistan in 2006 to that in 2011?
Ensure brevity in your answer.  0.42. What is the ratio of the Aid flow from DAC donars (current US$) of Kazakhstan in 2006 to that in 2011?
Give a very brief answer. 2.11. What is the ratio of the Aid flow from DAC donars (current US$) of Caribbean small states in 2007 to that in 2008?
Offer a terse response. 0.9. What is the ratio of the Aid flow from DAC donars (current US$) in Afghanistan in 2007 to that in 2008?
Ensure brevity in your answer.  0.76. What is the ratio of the Aid flow from DAC donars (current US$) in Kazakhstan in 2007 to that in 2008?
Offer a terse response. 0.78. What is the ratio of the Aid flow from DAC donars (current US$) in Caribbean small states in 2007 to that in 2009?
Offer a very short reply. 0.78. What is the ratio of the Aid flow from DAC donars (current US$) in Afghanistan in 2007 to that in 2009?
Make the answer very short. 0.6. What is the ratio of the Aid flow from DAC donars (current US$) in Kazakhstan in 2007 to that in 2009?
Offer a terse response. 1.03. What is the ratio of the Aid flow from DAC donars (current US$) of Caribbean small states in 2007 to that in 2010?
Ensure brevity in your answer.  0.85. What is the ratio of the Aid flow from DAC donars (current US$) of Afghanistan in 2007 to that in 2010?
Your response must be concise. 0.57. What is the ratio of the Aid flow from DAC donars (current US$) in Kazakhstan in 2007 to that in 2010?
Your answer should be compact. 1.69. What is the ratio of the Aid flow from DAC donars (current US$) in Caribbean small states in 2007 to that in 2011?
Keep it short and to the point. 1.24. What is the ratio of the Aid flow from DAC donars (current US$) of Afghanistan in 2007 to that in 2011?
Your response must be concise. 0.53. What is the ratio of the Aid flow from DAC donars (current US$) of Kazakhstan in 2007 to that in 2011?
Your response must be concise. 3.64. What is the ratio of the Aid flow from DAC donars (current US$) of Caribbean small states in 2008 to that in 2009?
Offer a terse response. 0.86. What is the ratio of the Aid flow from DAC donars (current US$) in Afghanistan in 2008 to that in 2009?
Your answer should be compact. 0.79. What is the ratio of the Aid flow from DAC donars (current US$) of Kazakhstan in 2008 to that in 2009?
Your answer should be very brief. 1.32. What is the ratio of the Aid flow from DAC donars (current US$) of Caribbean small states in 2008 to that in 2010?
Your answer should be compact. 0.94. What is the ratio of the Aid flow from DAC donars (current US$) in Afghanistan in 2008 to that in 2010?
Ensure brevity in your answer.  0.75. What is the ratio of the Aid flow from DAC donars (current US$) of Kazakhstan in 2008 to that in 2010?
Offer a terse response. 2.16. What is the ratio of the Aid flow from DAC donars (current US$) of Caribbean small states in 2008 to that in 2011?
Provide a succinct answer. 1.38. What is the ratio of the Aid flow from DAC donars (current US$) in Afghanistan in 2008 to that in 2011?
Your response must be concise. 0.69. What is the ratio of the Aid flow from DAC donars (current US$) in Kazakhstan in 2008 to that in 2011?
Keep it short and to the point. 4.66. What is the ratio of the Aid flow from DAC donars (current US$) in Caribbean small states in 2009 to that in 2010?
Ensure brevity in your answer.  1.09. What is the ratio of the Aid flow from DAC donars (current US$) in Afghanistan in 2009 to that in 2010?
Keep it short and to the point. 0.95. What is the ratio of the Aid flow from DAC donars (current US$) in Kazakhstan in 2009 to that in 2010?
Provide a succinct answer. 1.64. What is the ratio of the Aid flow from DAC donars (current US$) of Caribbean small states in 2009 to that in 2011?
Offer a terse response. 1.6. What is the ratio of the Aid flow from DAC donars (current US$) in Afghanistan in 2009 to that in 2011?
Offer a very short reply. 0.87. What is the ratio of the Aid flow from DAC donars (current US$) of Kazakhstan in 2009 to that in 2011?
Keep it short and to the point. 3.54. What is the ratio of the Aid flow from DAC donars (current US$) of Caribbean small states in 2010 to that in 2011?
Make the answer very short. 1.47. What is the ratio of the Aid flow from DAC donars (current US$) in Afghanistan in 2010 to that in 2011?
Ensure brevity in your answer.  0.92. What is the ratio of the Aid flow from DAC donars (current US$) of Kazakhstan in 2010 to that in 2011?
Offer a terse response. 2.16. What is the difference between the highest and the second highest Aid flow from DAC donars (current US$) of Caribbean small states?
Offer a terse response. 3.85e+07. What is the difference between the highest and the second highest Aid flow from DAC donars (current US$) in Afghanistan?
Your answer should be compact. 5.34e+08. What is the difference between the highest and the second highest Aid flow from DAC donars (current US$) of Kazakhstan?
Provide a succinct answer. 3.38e+07. What is the difference between the highest and the lowest Aid flow from DAC donars (current US$) of Caribbean small states?
Your answer should be very brief. 2.84e+08. What is the difference between the highest and the lowest Aid flow from DAC donars (current US$) of Afghanistan?
Make the answer very short. 4.38e+09. What is the difference between the highest and the lowest Aid flow from DAC donars (current US$) in Kazakhstan?
Offer a very short reply. 1.97e+08. 